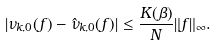<formula> <loc_0><loc_0><loc_500><loc_500>| \nu _ { k , 0 } ( f ) - \hat { \nu } _ { k , 0 } ( f ) | \leq \frac { K ( \beta ) } { N } \| f \| _ { \infty } .</formula> 